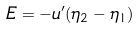<formula> <loc_0><loc_0><loc_500><loc_500>E = - u ^ { \prime } ( \eta _ { 2 } - \eta _ { 1 } )</formula> 